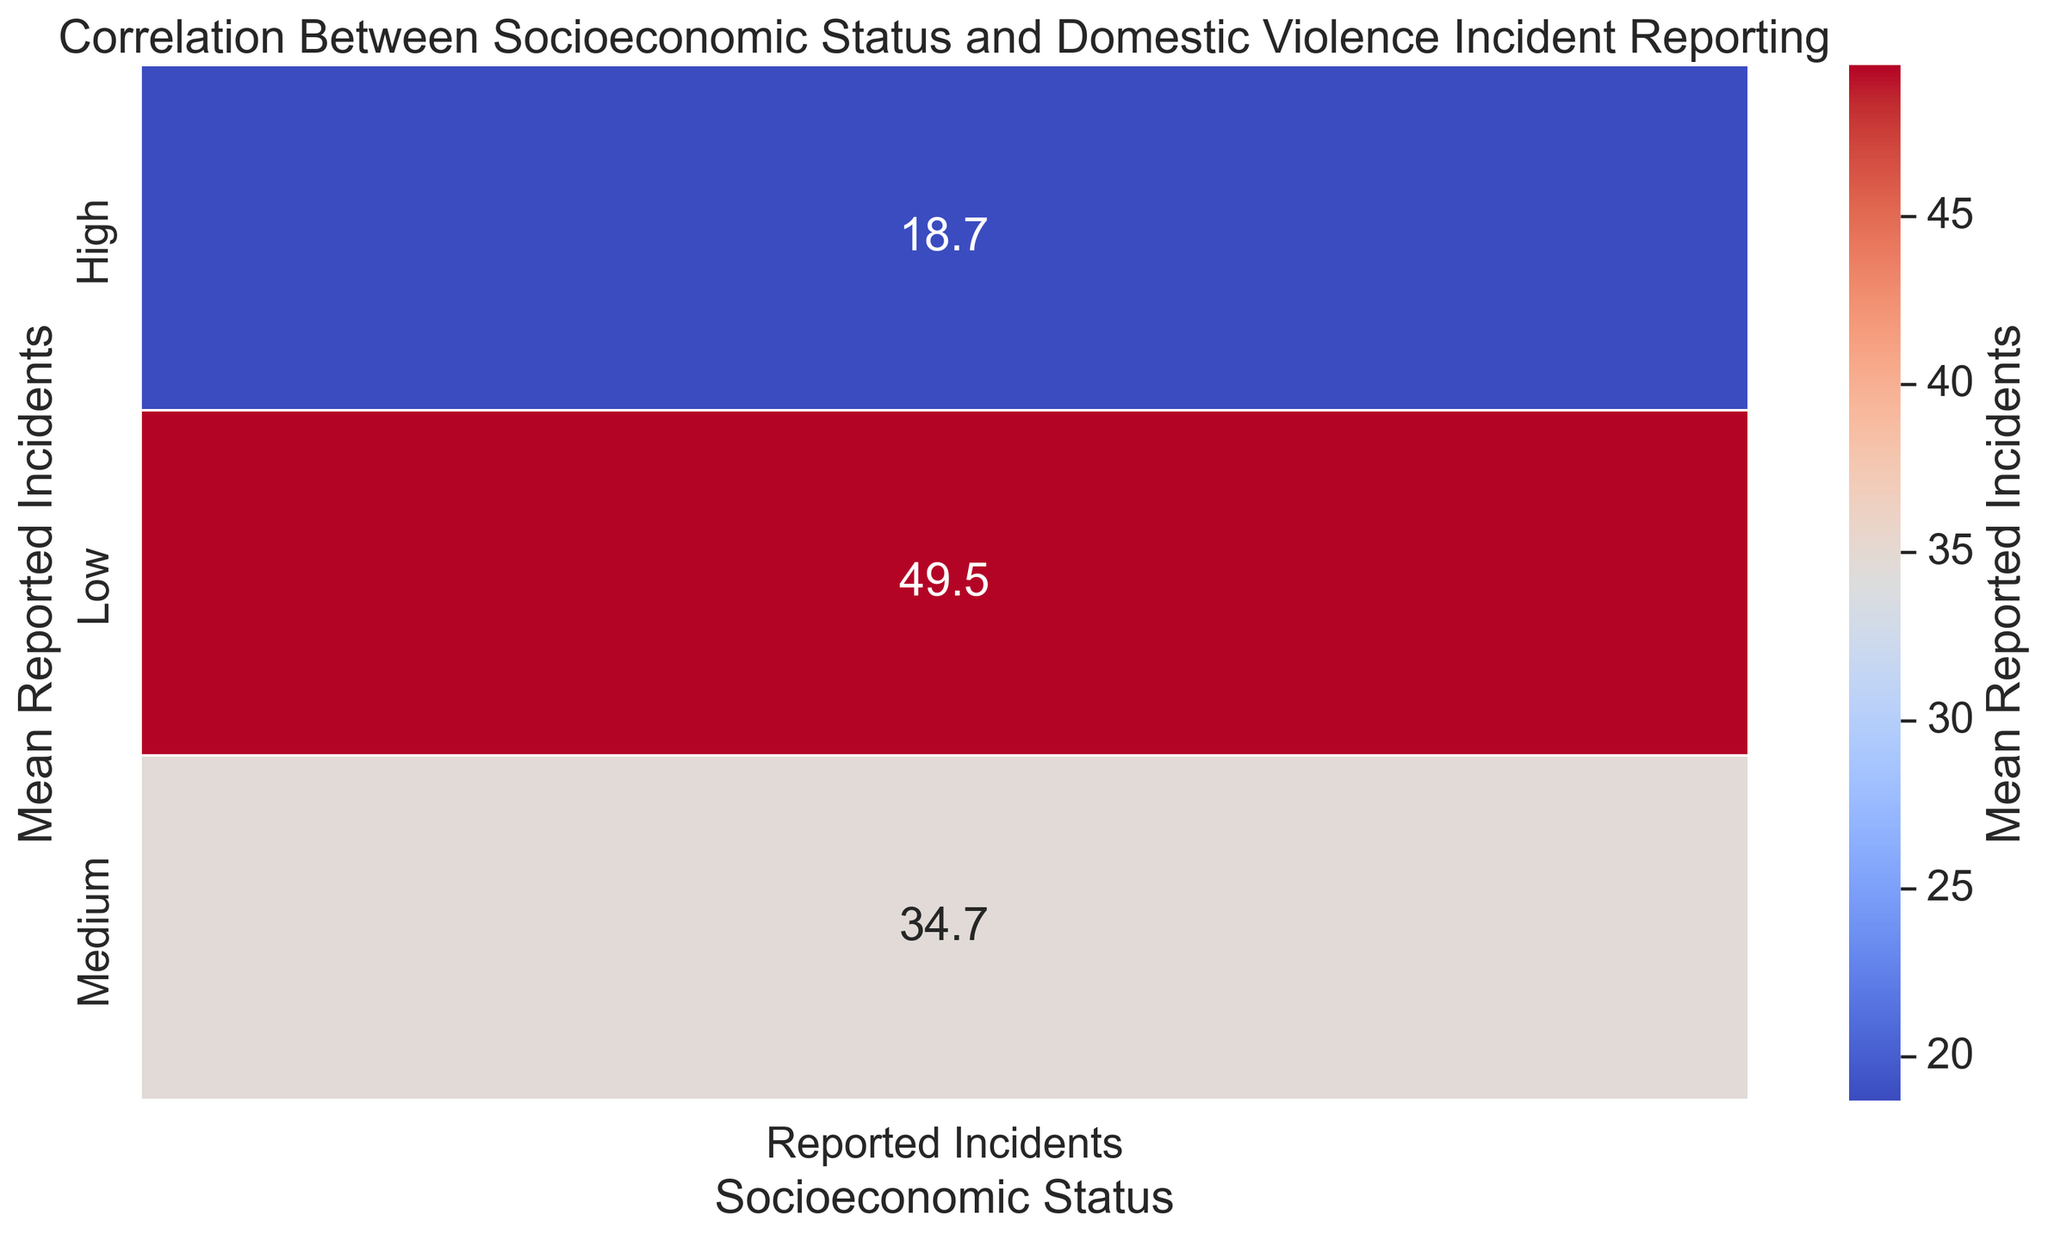What is the mean number of reported incidents in the high socioeconomic status group? The figure annotates the mean number of reported incidents for each socioeconomic status group. Find the high socioeconomic status group and read the annotated value.
Answer: 18.7 Which socioeconomic status group has the highest mean reported incidents? Look at the annotated values for the mean number of reported incidents in each socioeconomic status group and identify the highest value.
Answer: Low How does the mean reported incidents for the medium socioeconomic status group compare to that of the low socioeconomic status group? Find the annotated values for both the medium and low socioeconomic status groups and compare them.
Answer: Medium group is lower What is the difference in mean reported incidents between the medium and high socioeconomic status groups? Find the annotated values for the medium and high socioeconomic status groups and subtract the high group's mean from the medium group's mean.
Answer: 15.5 How much higher is the mean reported incidents in the low socioeconomic status group compared to the high socioeconomic status group? Find the annotated values for the low and high socioeconomic status groups. Subtract the high group's mean from the low group's mean.
Answer: 31.6 What general trend can be observed between socioeconomic status and mean reported incidents? Examine the overall pattern of the annotated mean reported incidents across different socioeconomic status groups. Determine if the values tend to increase or decrease with socioeconomic status.
Answer: Decreases with increasing socioeconomic status Based on the heatmap, what color represents the highest mean reported incidents and which socioeconomic status does it correspond to? Identify the color with the highest intensity on the heatmap, then look at the corresponding socioeconomic status annotation on the vertical axis.
Answer: Dark red, Low Is there any socioeconomic status group that has a mean reported incidents value that appears to be an outlier compared to the other groups? Examine the annotated mean values for any group that significantly deviates from the general trend.
Answer: No 